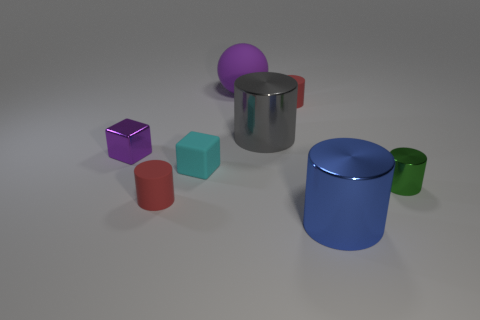Are there the same number of big shiny cylinders that are in front of the large blue metallic object and cyan rubber cubes to the left of the tiny purple cube?
Offer a very short reply. Yes. What shape is the small thing that is behind the purple metallic block?
Provide a short and direct response. Cylinder. What shape is the green metallic object that is the same size as the cyan rubber cube?
Give a very brief answer. Cylinder. The large object that is right of the tiny red thing behind the matte cylinder that is in front of the purple metal cube is what color?
Your answer should be very brief. Blue. Do the big blue thing and the large purple rubber thing have the same shape?
Your answer should be compact. No. Are there the same number of big purple things that are to the right of the green cylinder and large yellow matte blocks?
Your answer should be very brief. Yes. How many other objects are there of the same material as the tiny green cylinder?
Offer a terse response. 3. There is a red thing behind the tiny metallic block; is it the same size as the red thing to the left of the big rubber thing?
Ensure brevity in your answer.  Yes. How many things are large metallic things behind the metallic block or small cylinders that are on the right side of the large blue shiny object?
Provide a short and direct response. 2. Are there any other things that are the same shape as the cyan object?
Give a very brief answer. Yes. 